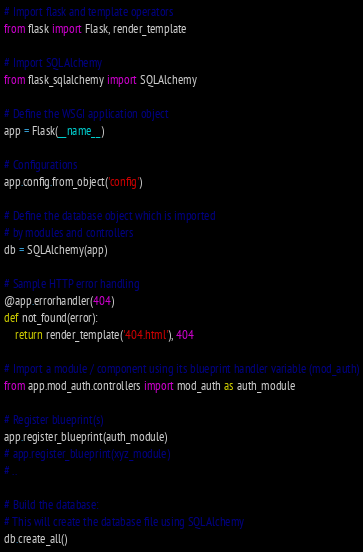<code> <loc_0><loc_0><loc_500><loc_500><_Python_># Import flask and template operators
from flask import Flask, render_template

# Import SQLAlchemy
from flask_sqlalchemy import SQLAlchemy

# Define the WSGI application object
app = Flask(__name__)

# Configurations
app.config.from_object('config')

# Define the database object which is imported
# by modules and controllers
db = SQLAlchemy(app)

# Sample HTTP error handling
@app.errorhandler(404)
def not_found(error):
    return render_template('404.html'), 404

# Import a module / component using its blueprint handler variable (mod_auth)
from app.mod_auth.controllers import mod_auth as auth_module

# Register blueprint(s)
app.register_blueprint(auth_module)
# app.register_blueprint(xyz_module)
# ..

# Build the database:
# This will create the database file using SQLAlchemy
db.create_all()

</code> 